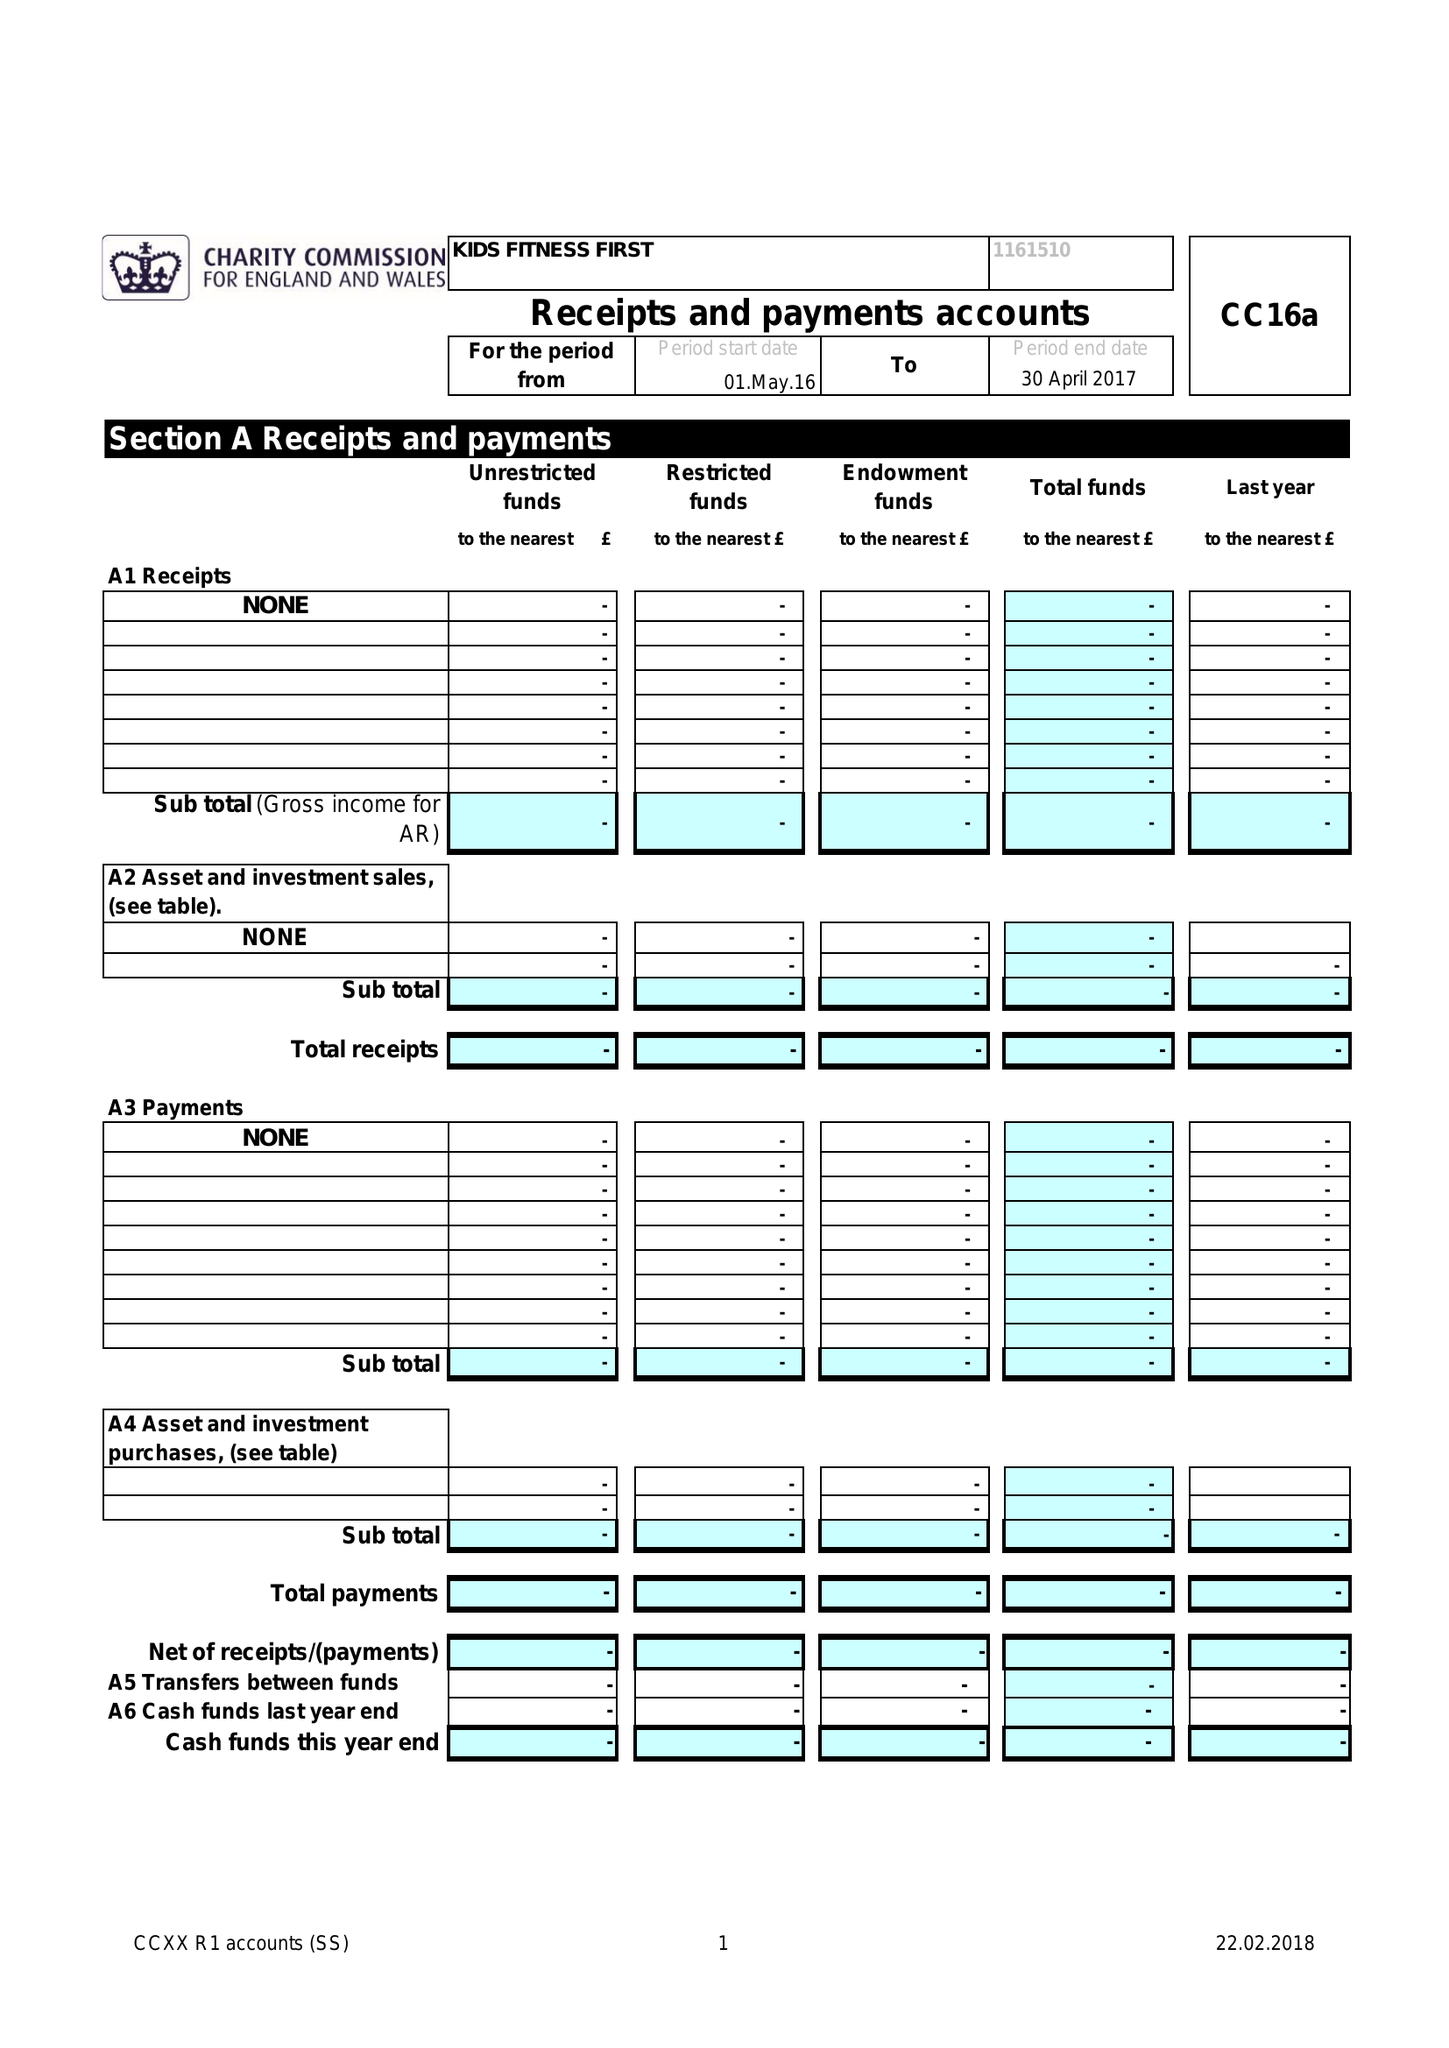What is the value for the spending_annually_in_british_pounds?
Answer the question using a single word or phrase. None 